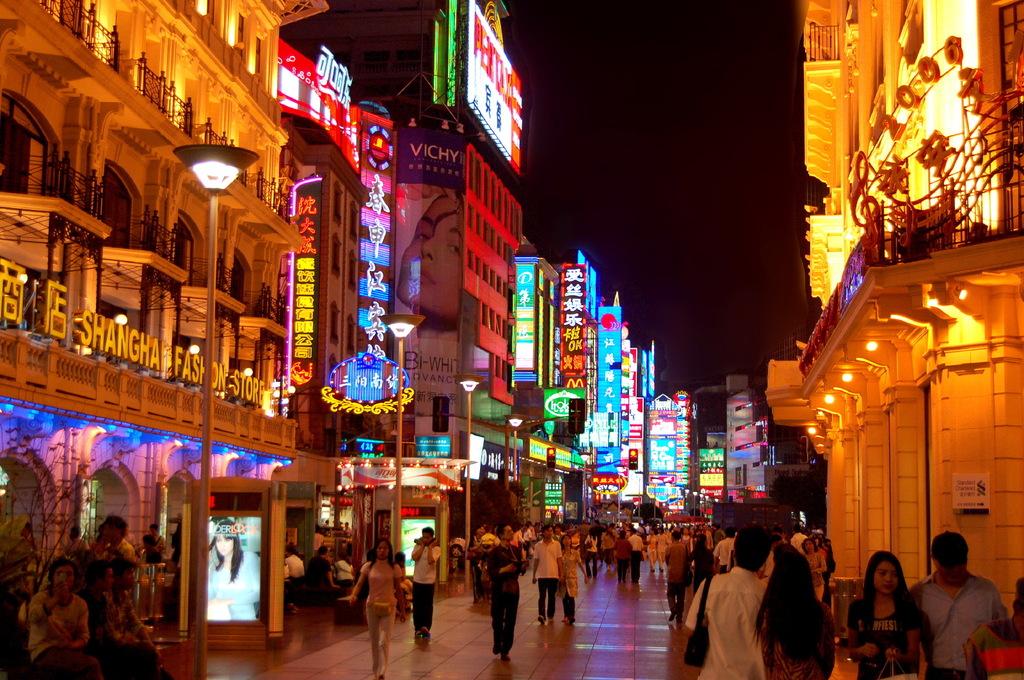What city is this?
Provide a short and direct response. Shanghai. What store is on the left?
Provide a short and direct response. Shanghai fashion store. 